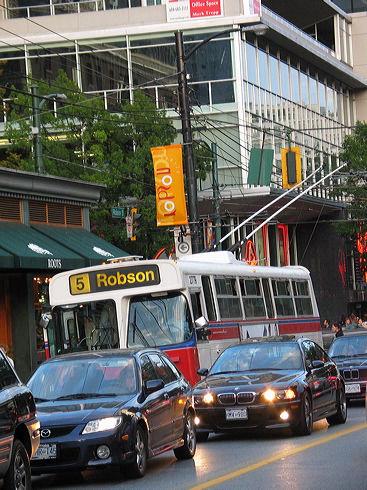Why do you like this photo?
Keep it brief. I don't. What number is written on the bus?
Short answer required. 5. Is this bus in a rural area?
Be succinct. No. 